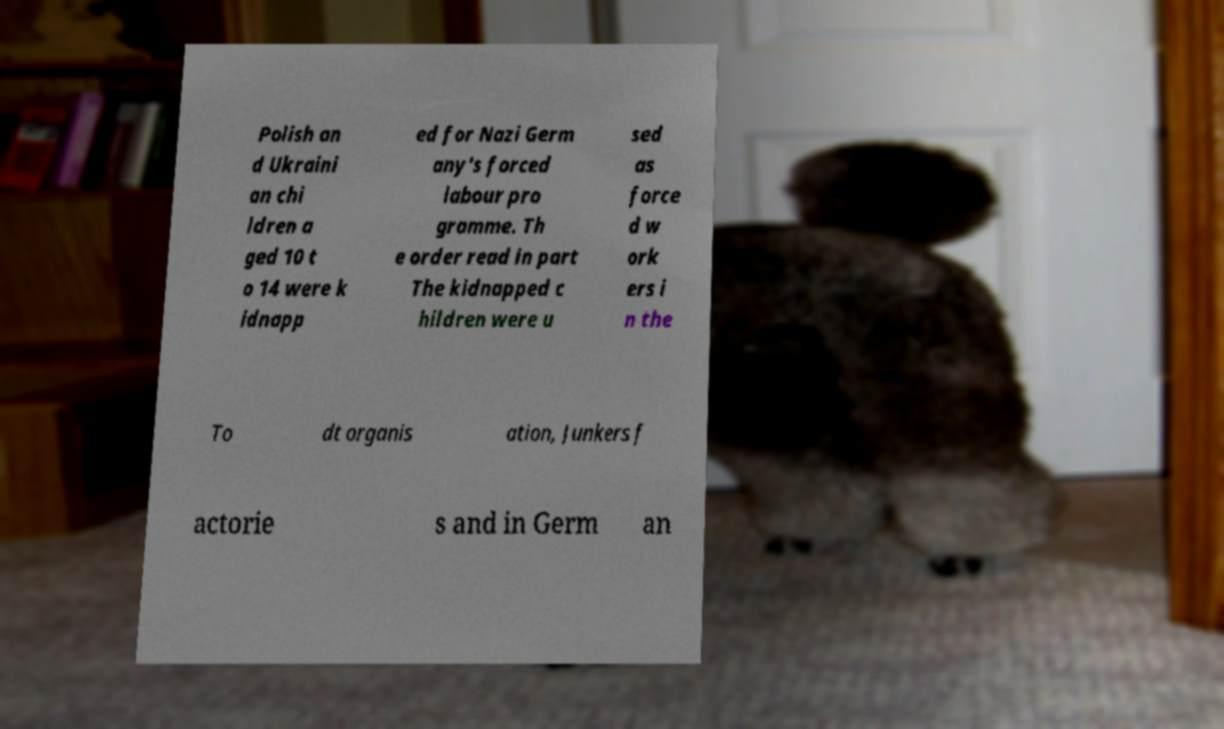What messages or text are displayed in this image? I need them in a readable, typed format. Polish an d Ukraini an chi ldren a ged 10 t o 14 were k idnapp ed for Nazi Germ any's forced labour pro gramme. Th e order read in part The kidnapped c hildren were u sed as force d w ork ers i n the To dt organis ation, Junkers f actorie s and in Germ an 